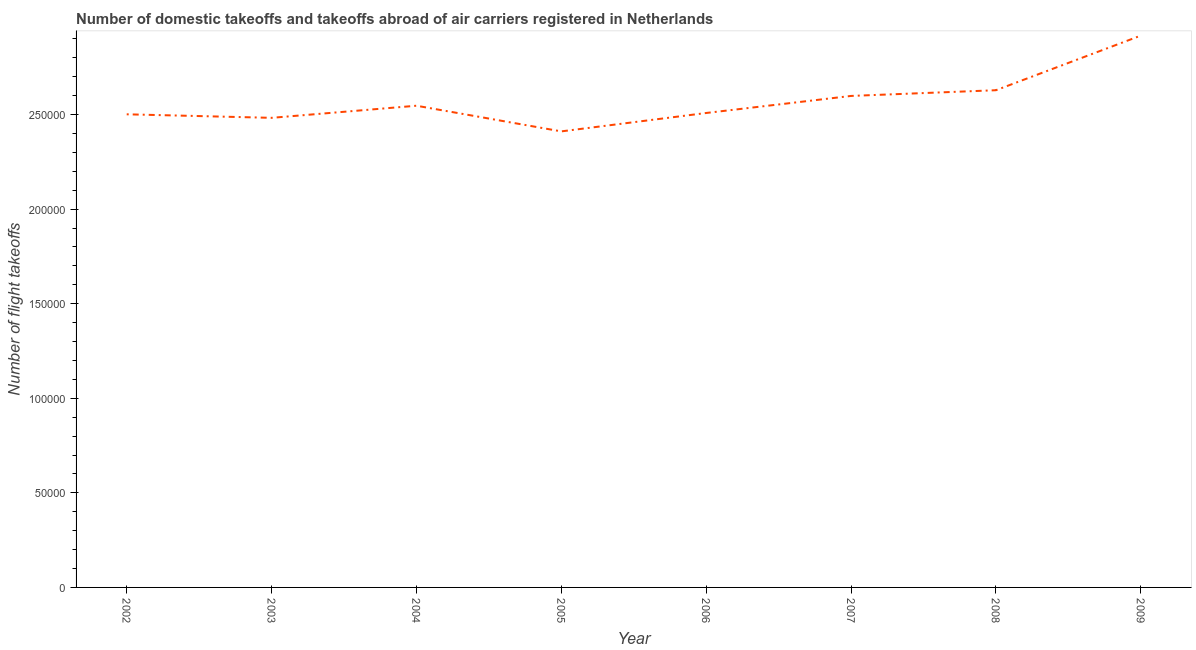What is the number of flight takeoffs in 2002?
Your answer should be compact. 2.50e+05. Across all years, what is the maximum number of flight takeoffs?
Provide a short and direct response. 2.92e+05. Across all years, what is the minimum number of flight takeoffs?
Ensure brevity in your answer.  2.41e+05. In which year was the number of flight takeoffs maximum?
Ensure brevity in your answer.  2009. In which year was the number of flight takeoffs minimum?
Ensure brevity in your answer.  2005. What is the sum of the number of flight takeoffs?
Provide a succinct answer. 2.06e+06. What is the difference between the number of flight takeoffs in 2002 and 2009?
Give a very brief answer. -4.16e+04. What is the average number of flight takeoffs per year?
Give a very brief answer. 2.57e+05. What is the median number of flight takeoffs?
Your answer should be very brief. 2.53e+05. Do a majority of the years between 2009 and 2008 (inclusive) have number of flight takeoffs greater than 130000 ?
Your answer should be compact. No. What is the ratio of the number of flight takeoffs in 2005 to that in 2008?
Your response must be concise. 0.92. What is the difference between the highest and the second highest number of flight takeoffs?
Offer a terse response. 2.89e+04. Is the sum of the number of flight takeoffs in 2003 and 2008 greater than the maximum number of flight takeoffs across all years?
Offer a very short reply. Yes. What is the difference between the highest and the lowest number of flight takeoffs?
Your response must be concise. 5.06e+04. Does the number of flight takeoffs monotonically increase over the years?
Give a very brief answer. No. How many lines are there?
Ensure brevity in your answer.  1. Does the graph contain any zero values?
Your answer should be compact. No. Does the graph contain grids?
Your answer should be very brief. No. What is the title of the graph?
Your response must be concise. Number of domestic takeoffs and takeoffs abroad of air carriers registered in Netherlands. What is the label or title of the X-axis?
Give a very brief answer. Year. What is the label or title of the Y-axis?
Make the answer very short. Number of flight takeoffs. What is the Number of flight takeoffs of 2002?
Offer a very short reply. 2.50e+05. What is the Number of flight takeoffs of 2003?
Keep it short and to the point. 2.48e+05. What is the Number of flight takeoffs of 2004?
Your answer should be very brief. 2.55e+05. What is the Number of flight takeoffs in 2005?
Ensure brevity in your answer.  2.41e+05. What is the Number of flight takeoffs of 2006?
Offer a very short reply. 2.51e+05. What is the Number of flight takeoffs of 2007?
Make the answer very short. 2.60e+05. What is the Number of flight takeoffs of 2008?
Provide a succinct answer. 2.63e+05. What is the Number of flight takeoffs in 2009?
Offer a very short reply. 2.92e+05. What is the difference between the Number of flight takeoffs in 2002 and 2003?
Ensure brevity in your answer.  1868. What is the difference between the Number of flight takeoffs in 2002 and 2004?
Your answer should be compact. -4533. What is the difference between the Number of flight takeoffs in 2002 and 2005?
Your answer should be compact. 9030. What is the difference between the Number of flight takeoffs in 2002 and 2006?
Give a very brief answer. -697. What is the difference between the Number of flight takeoffs in 2002 and 2007?
Give a very brief answer. -9713. What is the difference between the Number of flight takeoffs in 2002 and 2008?
Offer a very short reply. -1.27e+04. What is the difference between the Number of flight takeoffs in 2002 and 2009?
Provide a short and direct response. -4.16e+04. What is the difference between the Number of flight takeoffs in 2003 and 2004?
Your answer should be very brief. -6401. What is the difference between the Number of flight takeoffs in 2003 and 2005?
Offer a very short reply. 7162. What is the difference between the Number of flight takeoffs in 2003 and 2006?
Your answer should be compact. -2565. What is the difference between the Number of flight takeoffs in 2003 and 2007?
Make the answer very short. -1.16e+04. What is the difference between the Number of flight takeoffs in 2003 and 2008?
Ensure brevity in your answer.  -1.46e+04. What is the difference between the Number of flight takeoffs in 2003 and 2009?
Provide a succinct answer. -4.35e+04. What is the difference between the Number of flight takeoffs in 2004 and 2005?
Your answer should be compact. 1.36e+04. What is the difference between the Number of flight takeoffs in 2004 and 2006?
Give a very brief answer. 3836. What is the difference between the Number of flight takeoffs in 2004 and 2007?
Offer a terse response. -5180. What is the difference between the Number of flight takeoffs in 2004 and 2008?
Your answer should be very brief. -8201. What is the difference between the Number of flight takeoffs in 2004 and 2009?
Offer a terse response. -3.71e+04. What is the difference between the Number of flight takeoffs in 2005 and 2006?
Make the answer very short. -9727. What is the difference between the Number of flight takeoffs in 2005 and 2007?
Provide a short and direct response. -1.87e+04. What is the difference between the Number of flight takeoffs in 2005 and 2008?
Ensure brevity in your answer.  -2.18e+04. What is the difference between the Number of flight takeoffs in 2005 and 2009?
Your answer should be compact. -5.06e+04. What is the difference between the Number of flight takeoffs in 2006 and 2007?
Your answer should be very brief. -9016. What is the difference between the Number of flight takeoffs in 2006 and 2008?
Offer a very short reply. -1.20e+04. What is the difference between the Number of flight takeoffs in 2006 and 2009?
Give a very brief answer. -4.09e+04. What is the difference between the Number of flight takeoffs in 2007 and 2008?
Your answer should be very brief. -3021. What is the difference between the Number of flight takeoffs in 2007 and 2009?
Make the answer very short. -3.19e+04. What is the difference between the Number of flight takeoffs in 2008 and 2009?
Provide a succinct answer. -2.89e+04. What is the ratio of the Number of flight takeoffs in 2002 to that in 2005?
Keep it short and to the point. 1.04. What is the ratio of the Number of flight takeoffs in 2002 to that in 2009?
Your answer should be very brief. 0.86. What is the ratio of the Number of flight takeoffs in 2003 to that in 2004?
Your answer should be compact. 0.97. What is the ratio of the Number of flight takeoffs in 2003 to that in 2006?
Give a very brief answer. 0.99. What is the ratio of the Number of flight takeoffs in 2003 to that in 2007?
Your answer should be compact. 0.95. What is the ratio of the Number of flight takeoffs in 2003 to that in 2008?
Offer a very short reply. 0.94. What is the ratio of the Number of flight takeoffs in 2003 to that in 2009?
Your response must be concise. 0.85. What is the ratio of the Number of flight takeoffs in 2004 to that in 2005?
Offer a terse response. 1.06. What is the ratio of the Number of flight takeoffs in 2004 to that in 2007?
Ensure brevity in your answer.  0.98. What is the ratio of the Number of flight takeoffs in 2004 to that in 2008?
Ensure brevity in your answer.  0.97. What is the ratio of the Number of flight takeoffs in 2004 to that in 2009?
Your answer should be very brief. 0.87. What is the ratio of the Number of flight takeoffs in 2005 to that in 2006?
Give a very brief answer. 0.96. What is the ratio of the Number of flight takeoffs in 2005 to that in 2007?
Your response must be concise. 0.93. What is the ratio of the Number of flight takeoffs in 2005 to that in 2008?
Provide a succinct answer. 0.92. What is the ratio of the Number of flight takeoffs in 2005 to that in 2009?
Your answer should be very brief. 0.83. What is the ratio of the Number of flight takeoffs in 2006 to that in 2008?
Ensure brevity in your answer.  0.95. What is the ratio of the Number of flight takeoffs in 2006 to that in 2009?
Provide a short and direct response. 0.86. What is the ratio of the Number of flight takeoffs in 2007 to that in 2008?
Give a very brief answer. 0.99. What is the ratio of the Number of flight takeoffs in 2007 to that in 2009?
Ensure brevity in your answer.  0.89. What is the ratio of the Number of flight takeoffs in 2008 to that in 2009?
Give a very brief answer. 0.9. 